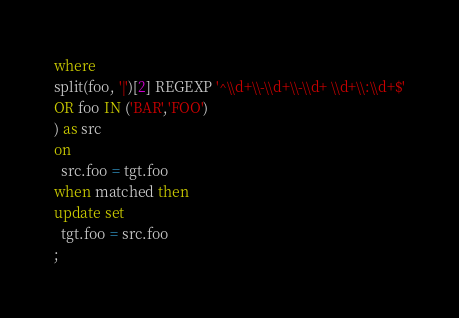Convert code to text. <code><loc_0><loc_0><loc_500><loc_500><_SQL_>where
split(foo, '|')[2] REGEXP '^\\d+\\-\\d+\\-\\d+ \\d+\\:\\d+$'
OR foo IN ('BAR','FOO')
) as src
on
  src.foo = tgt.foo
when matched then
update set
  tgt.foo = src.foo
;
</code> 